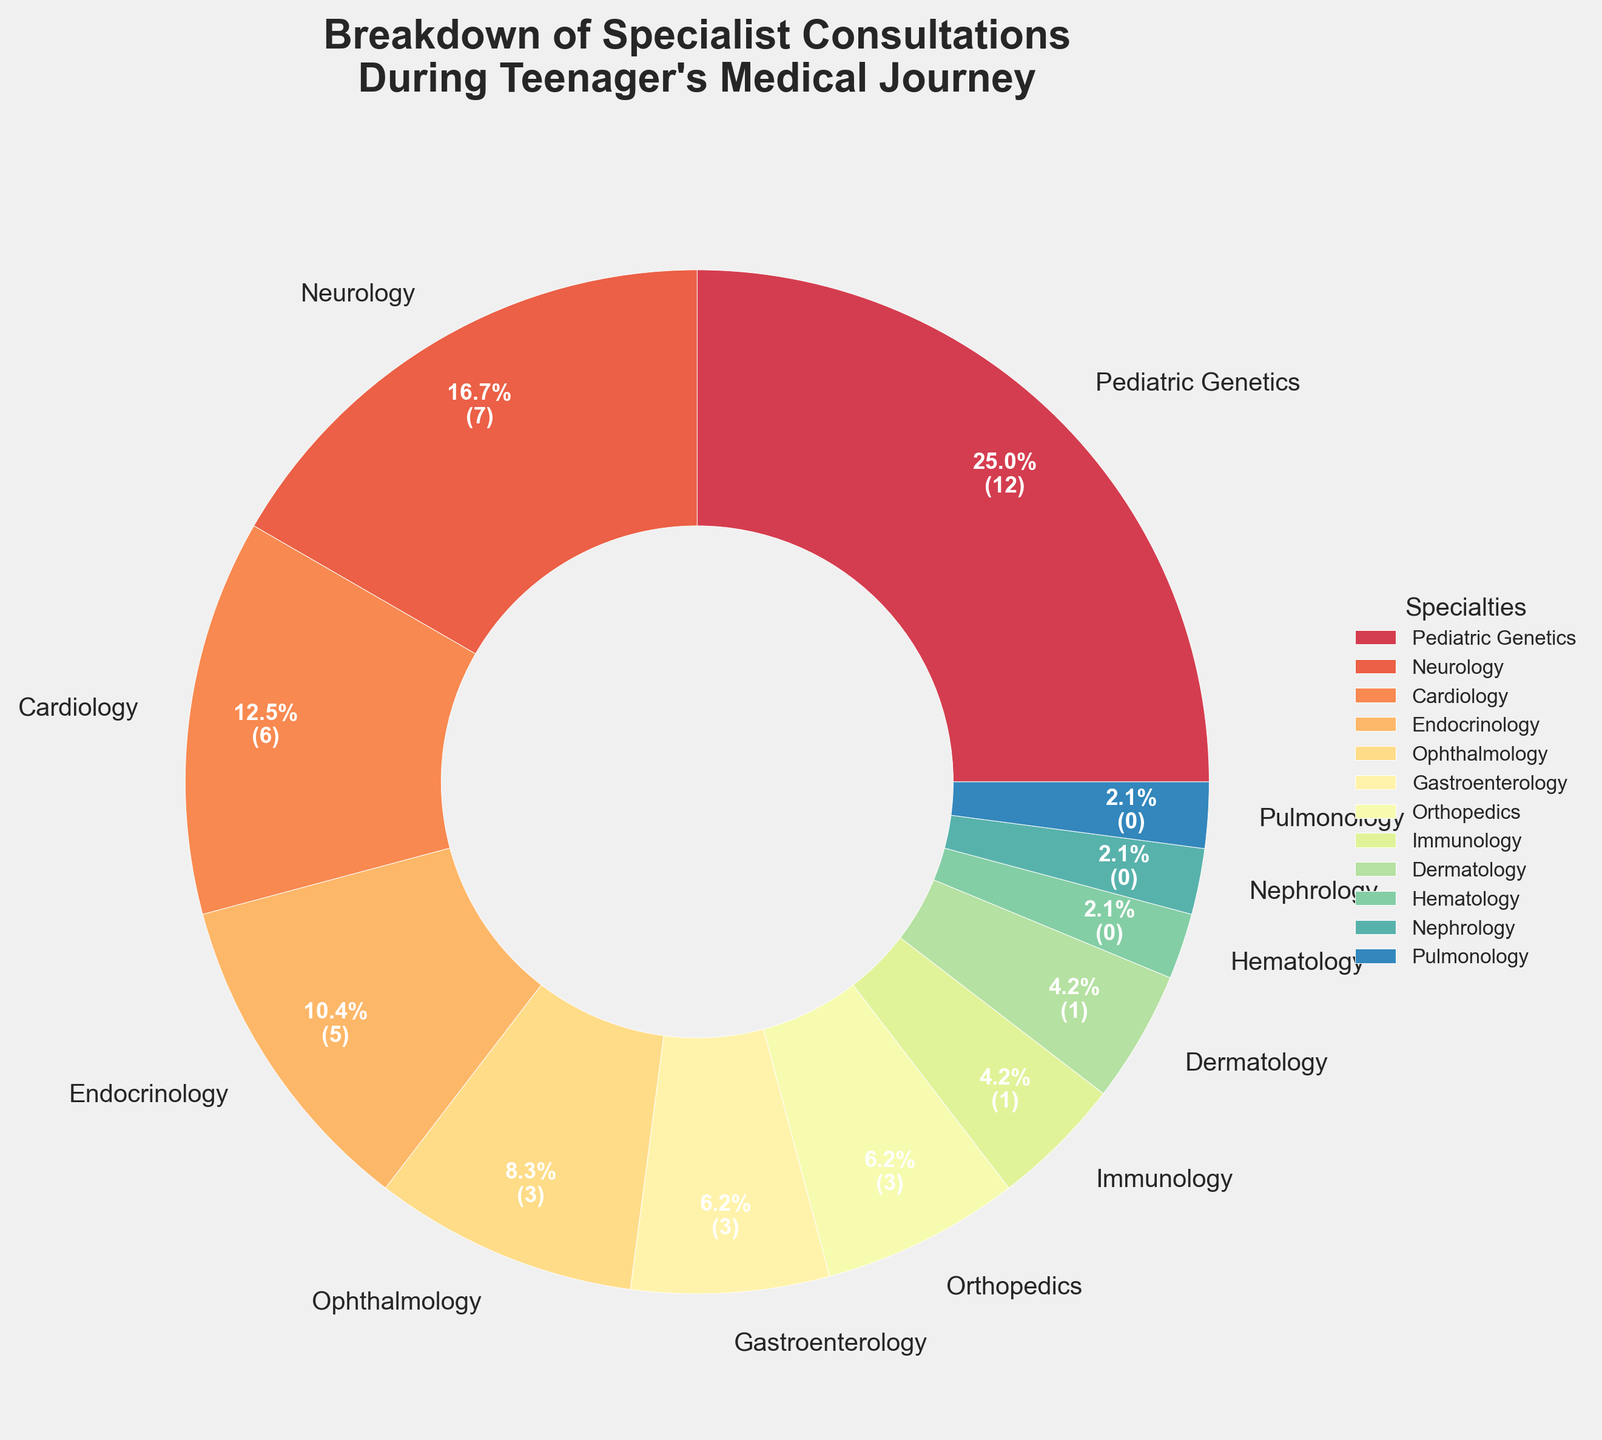What percentage of consultations were with Pediatric Genetics? First, identify Pediatric Genetics in the pie chart. The label and the percentage value next to it show 30.0%.
Answer: 30.0% Which specialty had the least number of consultations? Locate the smallest section of the pie chart and identify its label. Pulmonology, Nephrology, and Hematology each have 2.5%.
Answer: Pulmonology, Nephrology, and Hematology How many more consultations were there with Neurology compared to Endocrinology? Find the number of consultations for both Neurology (8) and Endocrinology (5). Subtract the smaller number from the larger one: 8 - 5 = 3.
Answer: 3 Which two specialties, when combined, contribute to the same percentage of consultations as Pediatric Genetics alone? Pediatric Genetics alone contributes 30.0%. Identify two other specialties whose combined percentages equal this. Neurology (20.0%) + Endocrinology (12.5%) sum up to 32.5%. Adjust to find a closer match; Neurology (20%) + Ophthalmology (10.0%) sum up to exactly 30.0%.
Answer: Neurology and Ophthalmology What is the combined percentage of consultations for specialties with fewer than 5 consultations each? Identify the specialties with fewer than 5 consultations: Orthopedics (3), Gastroenterology (3), Dermatology (2), Immunology (2), Pulmonology (1), Nephrology (1), Hematology (1). Sum their respective percentages. (7.5% + 7.5% + 5.0% + 5.0% + 2.5% + 2.5% + 2.5%). Total = 37.5%.
Answer: 37.5% What's the most dominant visual attribute of the highest consultation segment? Identify the highest consultation segment (Pediatric Genetics) and describe its visual characteristics. It's the largest wedge in the pie chart, prominent color, labelled 30.0%
Answer: Largest wedge How much larger is the percentage of Pediatric Genetics compared to Cardiology? Identify the percentages for Pediatric Genetics (30.0%) and Cardiology (15.0%). Subtract the smaller percentage from the larger one: 30.0% - 15.0% = 15.0%.
Answer: 15.0% What is the average number of consultations for the specialties that had more than 5 consultations? Identify the specialties with more than 5 consultations: Pediatric Genetics (12), Neurology (8), Cardiology (6). Add these numbers together (12 + 8 + 6 = 26). Divide by the number of specialties (26 / 3 = ~8.67).
Answer: ~8.67 